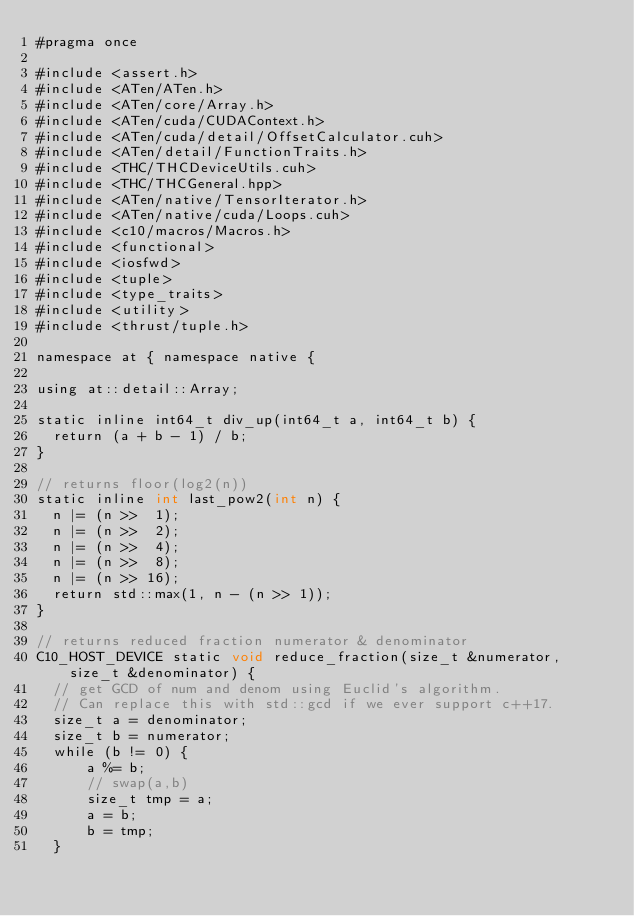<code> <loc_0><loc_0><loc_500><loc_500><_Cuda_>#pragma once

#include <assert.h>
#include <ATen/ATen.h>
#include <ATen/core/Array.h>
#include <ATen/cuda/CUDAContext.h>
#include <ATen/cuda/detail/OffsetCalculator.cuh>
#include <ATen/detail/FunctionTraits.h>
#include <THC/THCDeviceUtils.cuh>
#include <THC/THCGeneral.hpp>
#include <ATen/native/TensorIterator.h>
#include <ATen/native/cuda/Loops.cuh>
#include <c10/macros/Macros.h>
#include <functional>
#include <iosfwd>
#include <tuple>
#include <type_traits>
#include <utility>
#include <thrust/tuple.h>

namespace at { namespace native {

using at::detail::Array;

static inline int64_t div_up(int64_t a, int64_t b) {
  return (a + b - 1) / b;
}

// returns floor(log2(n))
static inline int last_pow2(int n) {
  n |= (n >>  1);
  n |= (n >>  2);
  n |= (n >>  4);
  n |= (n >>  8);
  n |= (n >> 16);
  return std::max(1, n - (n >> 1));
}

// returns reduced fraction numerator & denominator
C10_HOST_DEVICE static void reduce_fraction(size_t &numerator, size_t &denominator) {
  // get GCD of num and denom using Euclid's algorithm.
  // Can replace this with std::gcd if we ever support c++17.
  size_t a = denominator;
  size_t b = numerator;
  while (b != 0) {
      a %= b;
      // swap(a,b)
      size_t tmp = a;
      a = b;
      b = tmp;
  }
</code> 